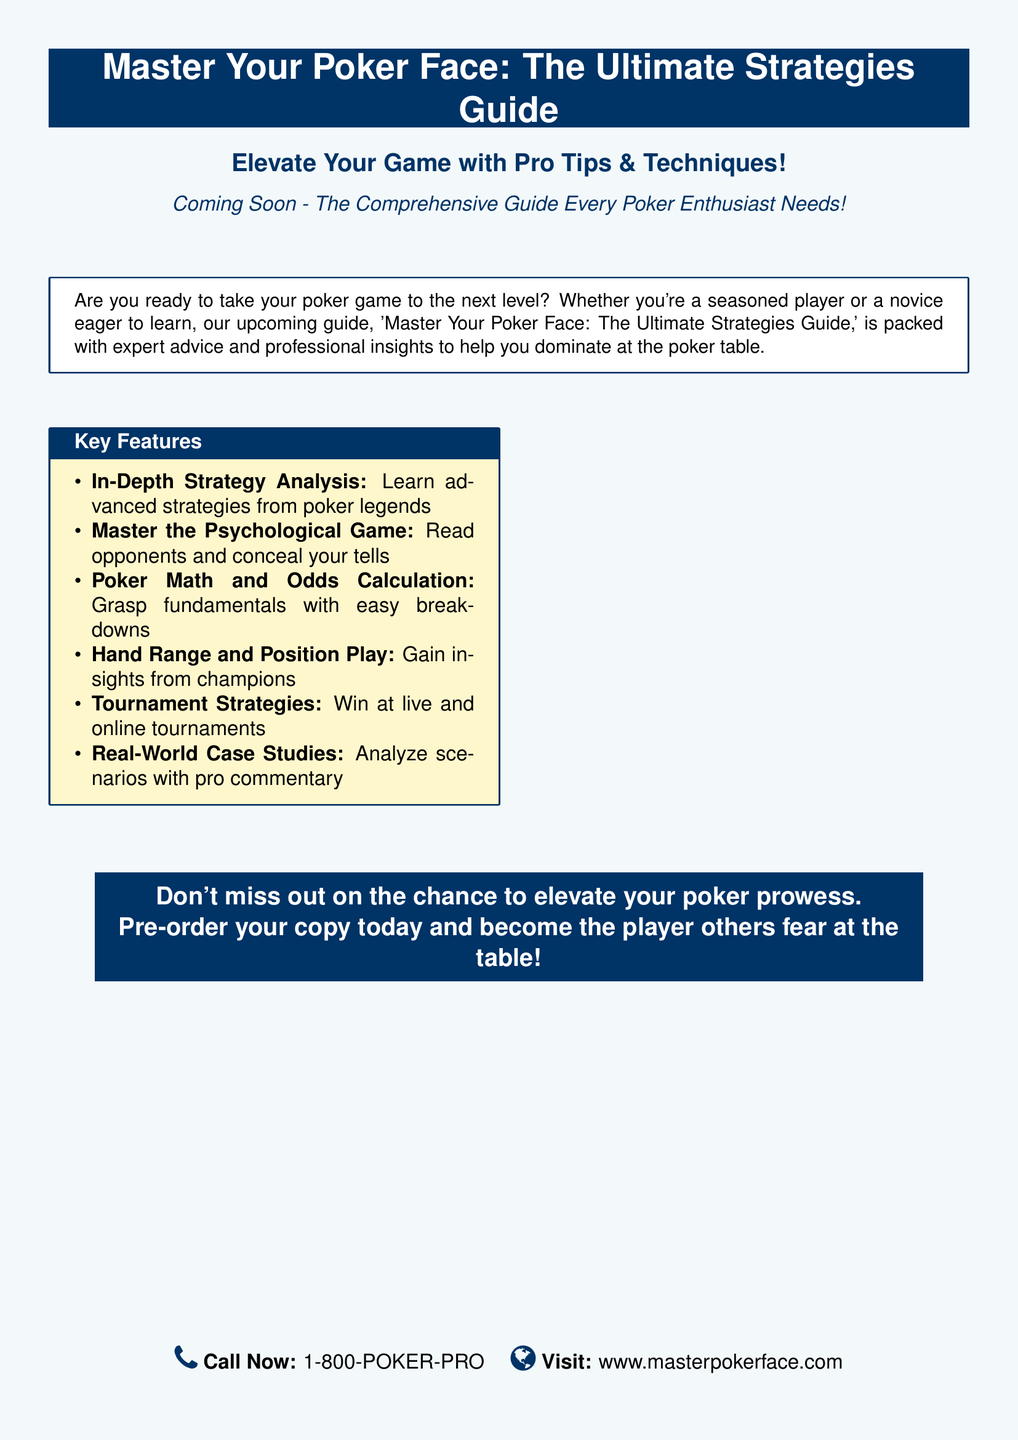What is the title of the guide? The title of the guide is prominently displayed in the advertisement.
Answer: Master Your Poker Face: The Ultimate Strategies Guide What is the phone number to call? The advertisement provides a specific phone number for inquiries.
Answer: 1-800-POKER-PRO What is one key feature of the guide? The document lists several key features that highlight important aspects of the guide.
Answer: In-Depth Strategy Analysis When is the guide coming out? The advertisement mentions when the guide will be available.
Answer: Coming Soon What type of insights does the guide offer? The advertisement indicates that the guide contains expert advice and professional insights.
Answer: Expert advice and professional insights What is the main purpose of the guide? The advertisement clearly states what the readers can achieve from the guide.
Answer: Elevate your game What should potential buyers do to get the guide? The advertisement provides an instruction for obtaining the guide.
Answer: Pre-order your copy today What is the website mentioned in the advertisement? The advertisement includes a website for more information.
Answer: www.masterpokerface.com What psychological aspect does the guide cover? The document mentions a specific psychological skill related to poker.
Answer: Master the Psychological Game What topics related to mathematics are addressed in the guide? The advertisement outlines a specific mathematical concept covered in the guide.
Answer: Poker Math and Odds Calculation 